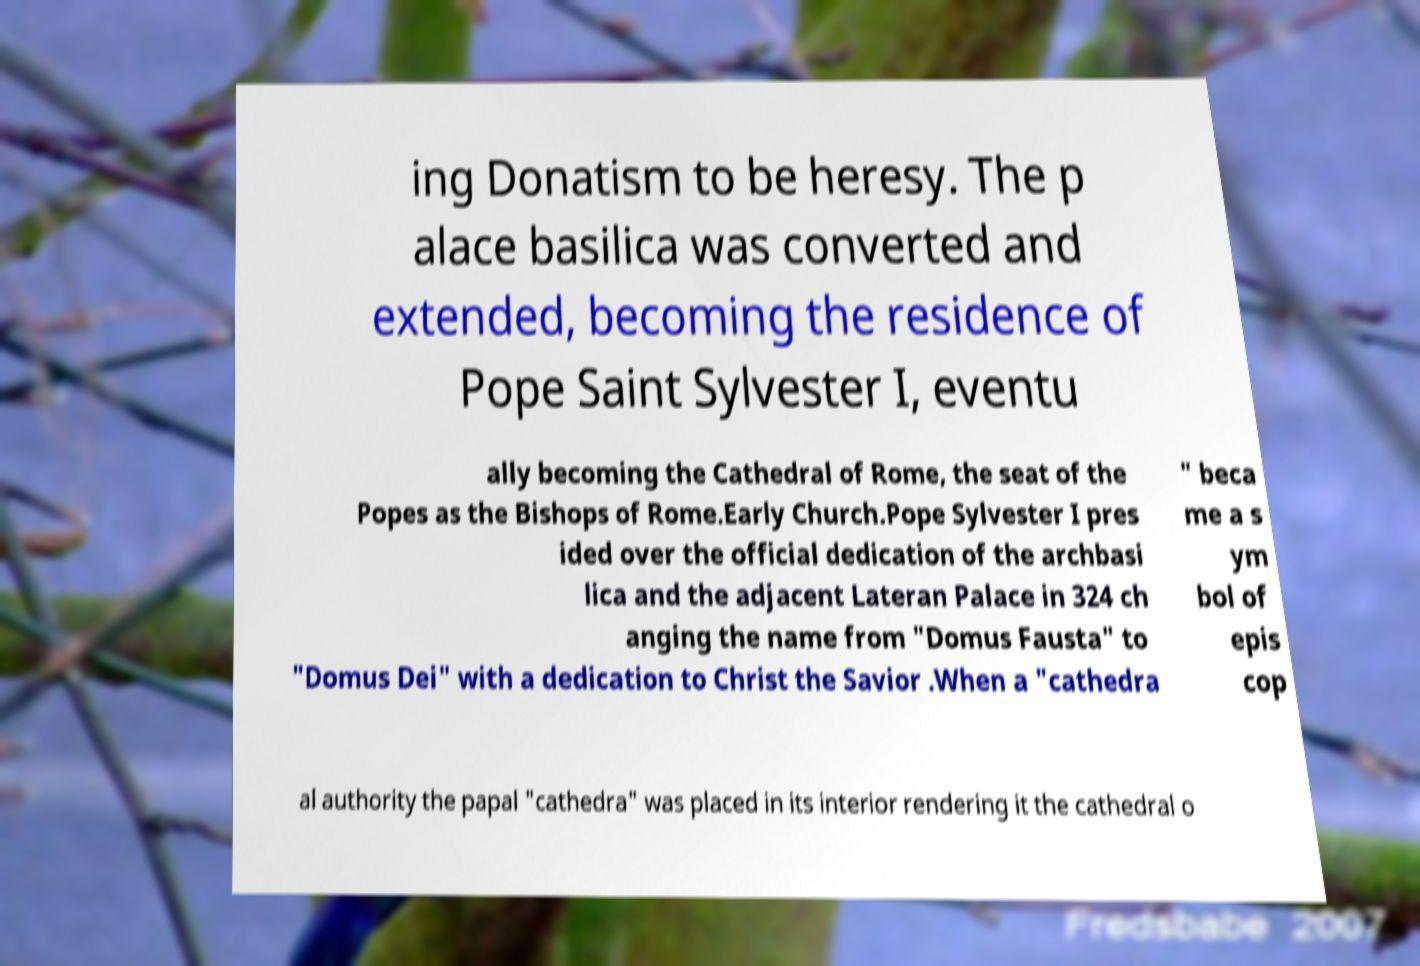Could you assist in decoding the text presented in this image and type it out clearly? ing Donatism to be heresy. The p alace basilica was converted and extended, becoming the residence of Pope Saint Sylvester I, eventu ally becoming the Cathedral of Rome, the seat of the Popes as the Bishops of Rome.Early Church.Pope Sylvester I pres ided over the official dedication of the archbasi lica and the adjacent Lateran Palace in 324 ch anging the name from "Domus Fausta" to "Domus Dei" with a dedication to Christ the Savior .When a "cathedra " beca me a s ym bol of epis cop al authority the papal "cathedra" was placed in its interior rendering it the cathedral o 